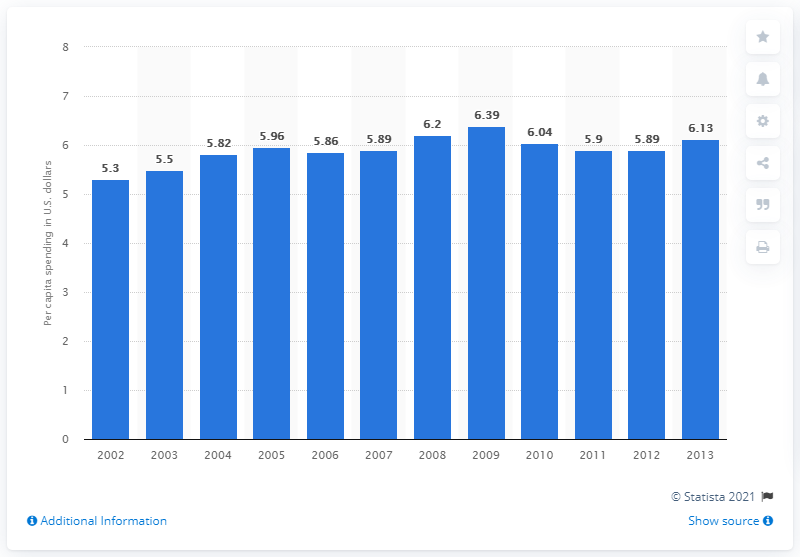Indicate a few pertinent items in this graphic. In 2013, federal institutions spent an average of 6.13 dollars per capita on arts and culture. 